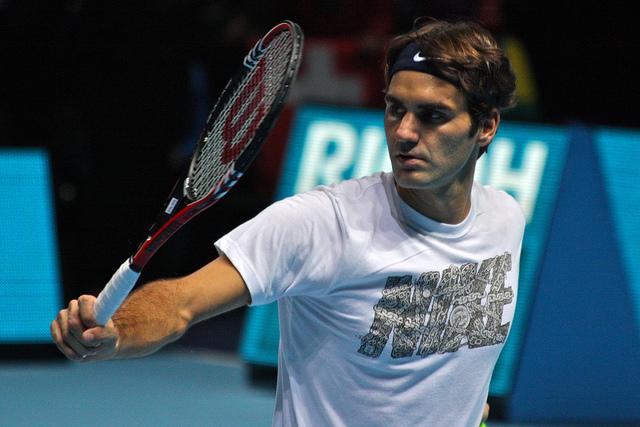What letter is on the racket?
Short answer required. W. What color is the man's shirt?
Be succinct. White. What game is the man playing?
Keep it brief. Tennis. Is this a professional player?
Short answer required. Yes. What sport is the man playing?
Answer briefly. Tennis. 